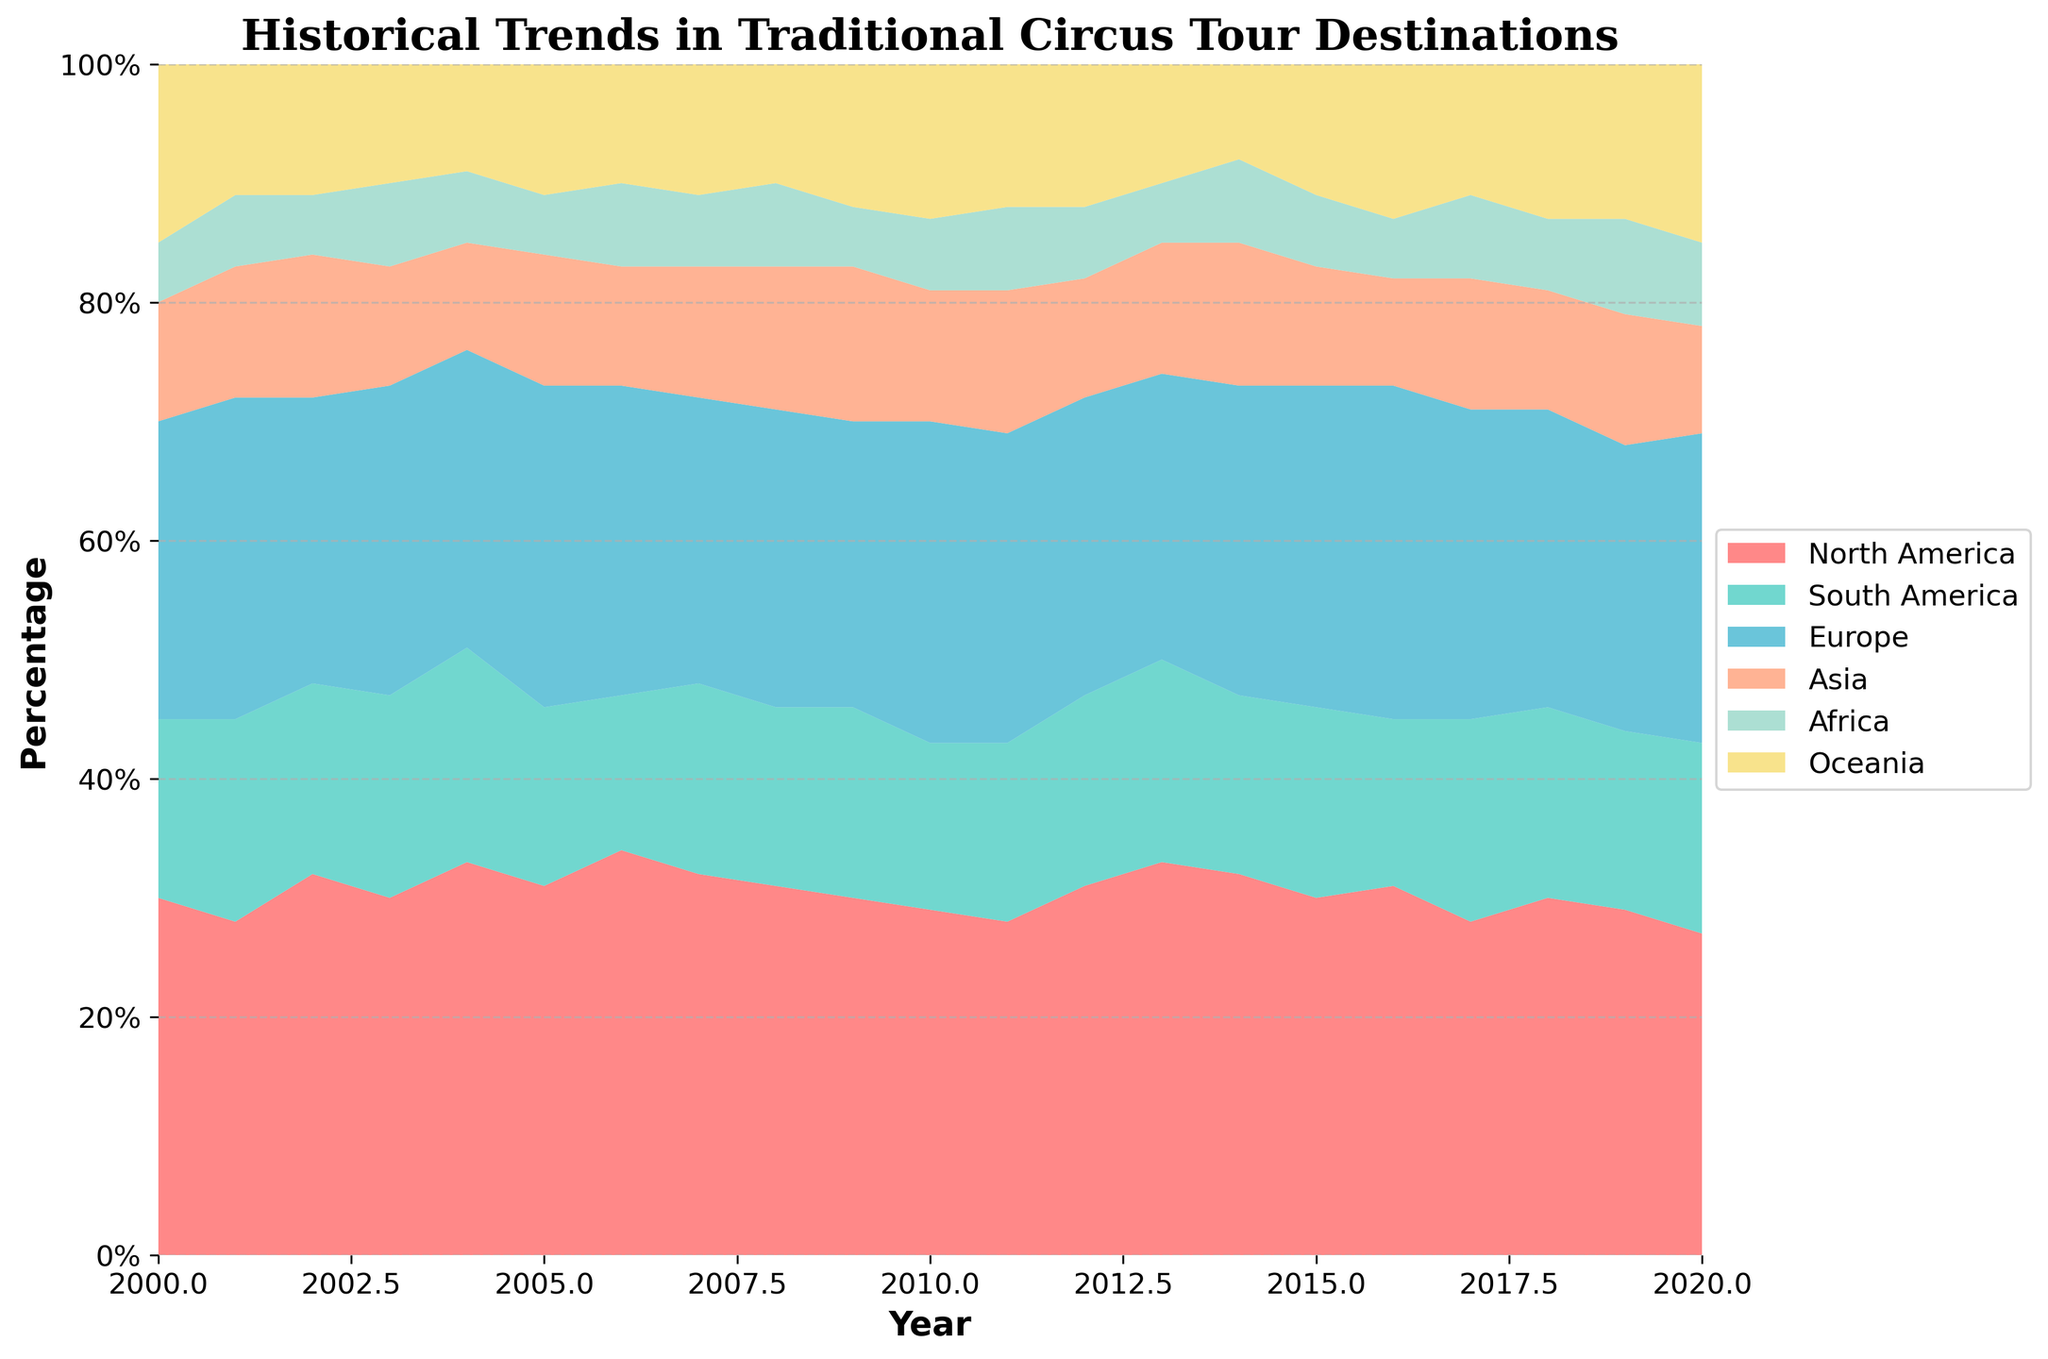What is the title of the figure? The title is located at the top of the chart and specifies the overall topic of the data being visualized.
Answer: Historical Trends in Traditional Circus Tour Destinations What is the percentage range displayed on the y-axis? The y-axis range is marked with percentages to show the relative distribution of circus tour destinations. The range typically spans from the smallest to the largest value marked on this axis.
Answer: 0% to 100% How does the percentage of circus tours in North America change from 2000 to 2020? Identify the section representing North America across the years and observe the trend. North America starts with a higher percentage and shows a slight decline towards 2020.
Answer: The percentage decreases Which continent shows a consistent percentage of circus tours from 2000 to 2020? Examine each colored area for uniformity across the years to find a continent whose percentage area remains relatively stable over the years. Oceania, represented by a relatively smaller and stable section, appears more consistent compared to others.
Answer: Oceania From 2003 to 2004, which continent shows an increase in the percentage of circus tours? Observe the colors for both 2003 and 2004, and locate the continent whose share grows. Europe shows an increase as its area grows in size.
Answer: Europe In which year did South America have the highest percentage of circus tours? Identify the section representing South America and track its highest peak across the years. The peak percentage is observed visually by the largest area at a specific year.
Answer: 2004 How does the percentage of circus tours in Asia compare from 2000 to 2020? Locate the sections for Asia in both years 2000 and 2020 and compare their sizes. Asia has a similar section in both years, indicating a consistent trend.
Answer: The percentage remains relatively stable Which continent has the most fluctuating percentage of circus tours from 2000 to 2020? Determine which color section shows considerable changes in size over the period. North America shows significant fluctuations indicating variability.
Answer: North America What is the combination percentage of tours in Africa and Europe in 2010? Look at the year 2010 and add the percentage areas of Africa and Europe together to find their combined share. This involves summing up visually estimated percentages.
Answer: Approximately 33% Which continent had the smallest percentage of circus tours in 2019? Identify the year 2019 and find the smallest colored section. Africa has the smallest share in that year.
Answer: Africa 